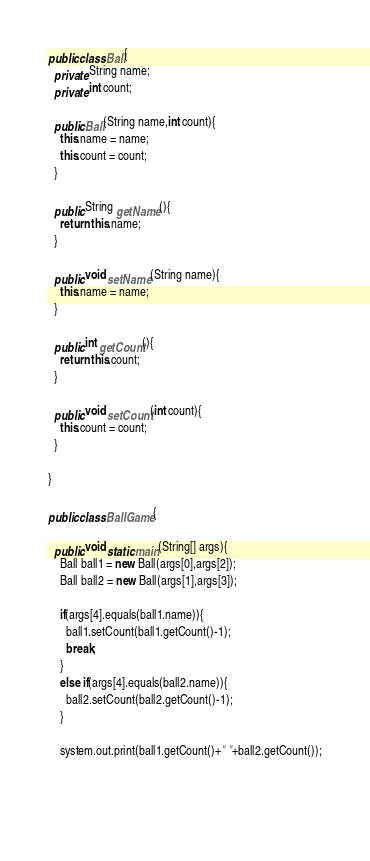Convert code to text. <code><loc_0><loc_0><loc_500><loc_500><_Java_>public class Ball{
  private String name;
  private int count;
  
  public Ball(String name,int count){
    this.name = name;
    this.count = count;
  }
  
  public String getName(){
    return this.name;
  }
  
  public void setName(String name){
    this.name = name;
  }
  
  public int getCount(){
    return this.count;
  }
  
  public void setCount(int count){
    this.count = count;
  }
   
}

public class BallGame{
  
  public void static main(String[] args){
    Ball ball1 = new Ball(args[0],args[2]);
    Ball ball2 = new Ball(args[1],args[3]);

    if(args[4].equals(ball1.name)){
      ball1.setCount(ball1.getCount()-1);
      break;
    }
    else if(args[4].equals(ball2.name)){
      ball2.setCount(ball2.getCount()-1);
    }
    
    system.out.print(ball1.getCount()+" "+ball2.getCount());
  
  
  </code> 